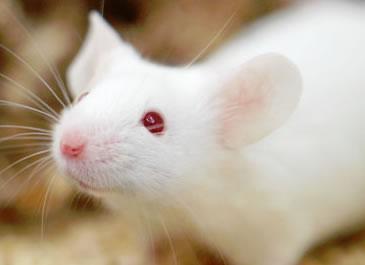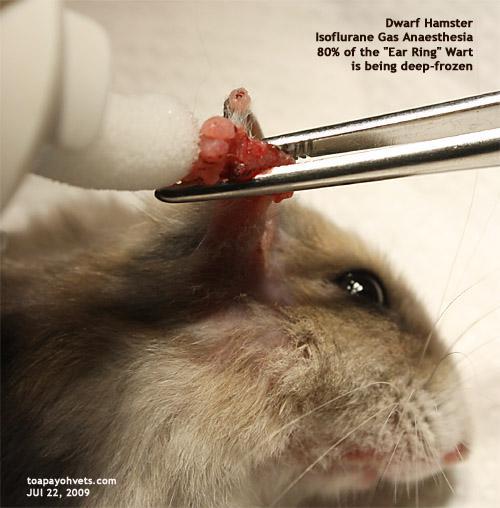The first image is the image on the left, the second image is the image on the right. Given the left and right images, does the statement "There is a mouse that is all white in color." hold true? Answer yes or no. Yes. The first image is the image on the left, the second image is the image on the right. Evaluate the accuracy of this statement regarding the images: "the animal in the image on the right is on all fours". Is it true? Answer yes or no. No. 